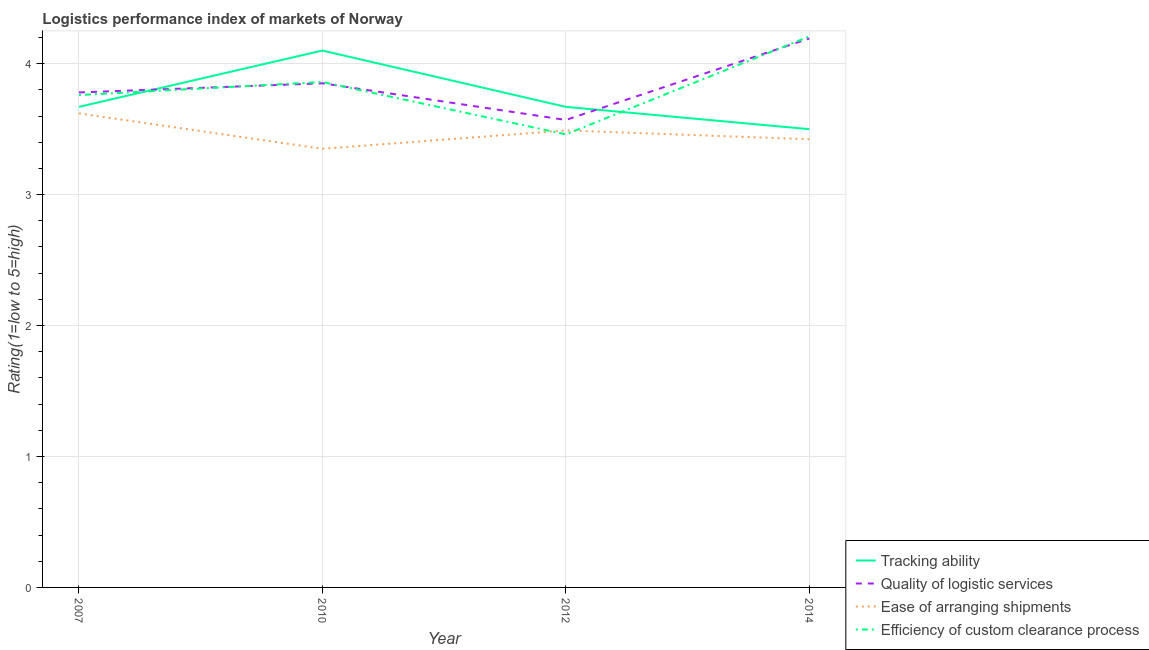Does the line corresponding to lpi rating of ease of arranging shipments intersect with the line corresponding to lpi rating of tracking ability?
Offer a terse response. No. Is the number of lines equal to the number of legend labels?
Your answer should be compact. Yes. What is the lpi rating of ease of arranging shipments in 2010?
Offer a very short reply. 3.35. Across all years, what is the maximum lpi rating of quality of logistic services?
Offer a very short reply. 4.19. Across all years, what is the minimum lpi rating of tracking ability?
Provide a succinct answer. 3.5. In which year was the lpi rating of tracking ability maximum?
Make the answer very short. 2010. What is the total lpi rating of tracking ability in the graph?
Your response must be concise. 14.94. What is the difference between the lpi rating of quality of logistic services in 2010 and that in 2012?
Provide a succinct answer. 0.28. What is the difference between the lpi rating of quality of logistic services in 2007 and the lpi rating of tracking ability in 2010?
Make the answer very short. -0.32. What is the average lpi rating of tracking ability per year?
Provide a succinct answer. 3.73. In the year 2012, what is the difference between the lpi rating of tracking ability and lpi rating of efficiency of custom clearance process?
Offer a very short reply. 0.21. What is the ratio of the lpi rating of quality of logistic services in 2012 to that in 2014?
Ensure brevity in your answer.  0.85. Is the lpi rating of tracking ability in 2007 less than that in 2012?
Provide a short and direct response. No. What is the difference between the highest and the second highest lpi rating of tracking ability?
Your response must be concise. 0.43. What is the difference between the highest and the lowest lpi rating of tracking ability?
Offer a terse response. 0.6. In how many years, is the lpi rating of tracking ability greater than the average lpi rating of tracking ability taken over all years?
Provide a short and direct response. 1. Is it the case that in every year, the sum of the lpi rating of ease of arranging shipments and lpi rating of quality of logistic services is greater than the sum of lpi rating of tracking ability and lpi rating of efficiency of custom clearance process?
Keep it short and to the point. No. Is it the case that in every year, the sum of the lpi rating of tracking ability and lpi rating of quality of logistic services is greater than the lpi rating of ease of arranging shipments?
Keep it short and to the point. Yes. Does the lpi rating of efficiency of custom clearance process monotonically increase over the years?
Your answer should be compact. No. Is the lpi rating of quality of logistic services strictly greater than the lpi rating of ease of arranging shipments over the years?
Provide a succinct answer. Yes. Is the lpi rating of ease of arranging shipments strictly less than the lpi rating of efficiency of custom clearance process over the years?
Make the answer very short. No. How many lines are there?
Keep it short and to the point. 4. How many years are there in the graph?
Make the answer very short. 4. Are the values on the major ticks of Y-axis written in scientific E-notation?
Ensure brevity in your answer.  No. Does the graph contain any zero values?
Give a very brief answer. No. Where does the legend appear in the graph?
Make the answer very short. Bottom right. How many legend labels are there?
Offer a terse response. 4. How are the legend labels stacked?
Your answer should be very brief. Vertical. What is the title of the graph?
Offer a very short reply. Logistics performance index of markets of Norway. What is the label or title of the X-axis?
Give a very brief answer. Year. What is the label or title of the Y-axis?
Offer a terse response. Rating(1=low to 5=high). What is the Rating(1=low to 5=high) in Tracking ability in 2007?
Keep it short and to the point. 3.67. What is the Rating(1=low to 5=high) of Quality of logistic services in 2007?
Your response must be concise. 3.78. What is the Rating(1=low to 5=high) of Ease of arranging shipments in 2007?
Give a very brief answer. 3.62. What is the Rating(1=low to 5=high) in Efficiency of custom clearance process in 2007?
Your answer should be compact. 3.76. What is the Rating(1=low to 5=high) in Tracking ability in 2010?
Your answer should be compact. 4.1. What is the Rating(1=low to 5=high) in Quality of logistic services in 2010?
Keep it short and to the point. 3.85. What is the Rating(1=low to 5=high) in Ease of arranging shipments in 2010?
Your response must be concise. 3.35. What is the Rating(1=low to 5=high) in Efficiency of custom clearance process in 2010?
Provide a succinct answer. 3.86. What is the Rating(1=low to 5=high) in Tracking ability in 2012?
Your answer should be compact. 3.67. What is the Rating(1=low to 5=high) in Quality of logistic services in 2012?
Offer a very short reply. 3.57. What is the Rating(1=low to 5=high) in Ease of arranging shipments in 2012?
Offer a very short reply. 3.49. What is the Rating(1=low to 5=high) of Efficiency of custom clearance process in 2012?
Ensure brevity in your answer.  3.46. What is the Rating(1=low to 5=high) of Tracking ability in 2014?
Provide a succinct answer. 3.5. What is the Rating(1=low to 5=high) in Quality of logistic services in 2014?
Give a very brief answer. 4.19. What is the Rating(1=low to 5=high) in Ease of arranging shipments in 2014?
Your answer should be very brief. 3.42. What is the Rating(1=low to 5=high) in Efficiency of custom clearance process in 2014?
Make the answer very short. 4.21. Across all years, what is the maximum Rating(1=low to 5=high) of Quality of logistic services?
Your response must be concise. 4.19. Across all years, what is the maximum Rating(1=low to 5=high) in Ease of arranging shipments?
Keep it short and to the point. 3.62. Across all years, what is the maximum Rating(1=low to 5=high) of Efficiency of custom clearance process?
Ensure brevity in your answer.  4.21. Across all years, what is the minimum Rating(1=low to 5=high) in Tracking ability?
Offer a very short reply. 3.5. Across all years, what is the minimum Rating(1=low to 5=high) of Quality of logistic services?
Your response must be concise. 3.57. Across all years, what is the minimum Rating(1=low to 5=high) of Ease of arranging shipments?
Ensure brevity in your answer.  3.35. Across all years, what is the minimum Rating(1=low to 5=high) of Efficiency of custom clearance process?
Ensure brevity in your answer.  3.46. What is the total Rating(1=low to 5=high) in Tracking ability in the graph?
Provide a succinct answer. 14.94. What is the total Rating(1=low to 5=high) in Quality of logistic services in the graph?
Your answer should be compact. 15.39. What is the total Rating(1=low to 5=high) in Ease of arranging shipments in the graph?
Keep it short and to the point. 13.88. What is the total Rating(1=low to 5=high) in Efficiency of custom clearance process in the graph?
Your answer should be very brief. 15.29. What is the difference between the Rating(1=low to 5=high) in Tracking ability in 2007 and that in 2010?
Offer a very short reply. -0.43. What is the difference between the Rating(1=low to 5=high) of Quality of logistic services in 2007 and that in 2010?
Make the answer very short. -0.07. What is the difference between the Rating(1=low to 5=high) of Ease of arranging shipments in 2007 and that in 2010?
Provide a succinct answer. 0.27. What is the difference between the Rating(1=low to 5=high) in Quality of logistic services in 2007 and that in 2012?
Provide a short and direct response. 0.21. What is the difference between the Rating(1=low to 5=high) of Ease of arranging shipments in 2007 and that in 2012?
Offer a very short reply. 0.13. What is the difference between the Rating(1=low to 5=high) of Efficiency of custom clearance process in 2007 and that in 2012?
Your answer should be very brief. 0.3. What is the difference between the Rating(1=low to 5=high) in Tracking ability in 2007 and that in 2014?
Give a very brief answer. 0.17. What is the difference between the Rating(1=low to 5=high) of Quality of logistic services in 2007 and that in 2014?
Your answer should be compact. -0.41. What is the difference between the Rating(1=low to 5=high) in Ease of arranging shipments in 2007 and that in 2014?
Ensure brevity in your answer.  0.2. What is the difference between the Rating(1=low to 5=high) of Efficiency of custom clearance process in 2007 and that in 2014?
Your answer should be very brief. -0.45. What is the difference between the Rating(1=low to 5=high) of Tracking ability in 2010 and that in 2012?
Offer a very short reply. 0.43. What is the difference between the Rating(1=low to 5=high) in Quality of logistic services in 2010 and that in 2012?
Your answer should be compact. 0.28. What is the difference between the Rating(1=low to 5=high) of Ease of arranging shipments in 2010 and that in 2012?
Your answer should be very brief. -0.14. What is the difference between the Rating(1=low to 5=high) in Efficiency of custom clearance process in 2010 and that in 2012?
Provide a short and direct response. 0.4. What is the difference between the Rating(1=low to 5=high) in Tracking ability in 2010 and that in 2014?
Make the answer very short. 0.6. What is the difference between the Rating(1=low to 5=high) in Quality of logistic services in 2010 and that in 2014?
Your response must be concise. -0.34. What is the difference between the Rating(1=low to 5=high) in Ease of arranging shipments in 2010 and that in 2014?
Make the answer very short. -0.07. What is the difference between the Rating(1=low to 5=high) of Efficiency of custom clearance process in 2010 and that in 2014?
Offer a terse response. -0.35. What is the difference between the Rating(1=low to 5=high) in Tracking ability in 2012 and that in 2014?
Offer a very short reply. 0.17. What is the difference between the Rating(1=low to 5=high) of Quality of logistic services in 2012 and that in 2014?
Your response must be concise. -0.62. What is the difference between the Rating(1=low to 5=high) of Ease of arranging shipments in 2012 and that in 2014?
Provide a succinct answer. 0.07. What is the difference between the Rating(1=low to 5=high) of Efficiency of custom clearance process in 2012 and that in 2014?
Make the answer very short. -0.75. What is the difference between the Rating(1=low to 5=high) in Tracking ability in 2007 and the Rating(1=low to 5=high) in Quality of logistic services in 2010?
Your answer should be very brief. -0.18. What is the difference between the Rating(1=low to 5=high) of Tracking ability in 2007 and the Rating(1=low to 5=high) of Ease of arranging shipments in 2010?
Provide a succinct answer. 0.32. What is the difference between the Rating(1=low to 5=high) of Tracking ability in 2007 and the Rating(1=low to 5=high) of Efficiency of custom clearance process in 2010?
Keep it short and to the point. -0.19. What is the difference between the Rating(1=low to 5=high) of Quality of logistic services in 2007 and the Rating(1=low to 5=high) of Ease of arranging shipments in 2010?
Give a very brief answer. 0.43. What is the difference between the Rating(1=low to 5=high) of Quality of logistic services in 2007 and the Rating(1=low to 5=high) of Efficiency of custom clearance process in 2010?
Give a very brief answer. -0.08. What is the difference between the Rating(1=low to 5=high) of Ease of arranging shipments in 2007 and the Rating(1=low to 5=high) of Efficiency of custom clearance process in 2010?
Your answer should be very brief. -0.24. What is the difference between the Rating(1=low to 5=high) in Tracking ability in 2007 and the Rating(1=low to 5=high) in Quality of logistic services in 2012?
Offer a very short reply. 0.1. What is the difference between the Rating(1=low to 5=high) of Tracking ability in 2007 and the Rating(1=low to 5=high) of Ease of arranging shipments in 2012?
Offer a very short reply. 0.18. What is the difference between the Rating(1=low to 5=high) in Tracking ability in 2007 and the Rating(1=low to 5=high) in Efficiency of custom clearance process in 2012?
Provide a succinct answer. 0.21. What is the difference between the Rating(1=low to 5=high) in Quality of logistic services in 2007 and the Rating(1=low to 5=high) in Ease of arranging shipments in 2012?
Make the answer very short. 0.29. What is the difference between the Rating(1=low to 5=high) in Quality of logistic services in 2007 and the Rating(1=low to 5=high) in Efficiency of custom clearance process in 2012?
Make the answer very short. 0.32. What is the difference between the Rating(1=low to 5=high) of Ease of arranging shipments in 2007 and the Rating(1=low to 5=high) of Efficiency of custom clearance process in 2012?
Provide a short and direct response. 0.16. What is the difference between the Rating(1=low to 5=high) of Tracking ability in 2007 and the Rating(1=low to 5=high) of Quality of logistic services in 2014?
Your response must be concise. -0.52. What is the difference between the Rating(1=low to 5=high) of Tracking ability in 2007 and the Rating(1=low to 5=high) of Ease of arranging shipments in 2014?
Give a very brief answer. 0.25. What is the difference between the Rating(1=low to 5=high) in Tracking ability in 2007 and the Rating(1=low to 5=high) in Efficiency of custom clearance process in 2014?
Keep it short and to the point. -0.54. What is the difference between the Rating(1=low to 5=high) of Quality of logistic services in 2007 and the Rating(1=low to 5=high) of Ease of arranging shipments in 2014?
Offer a very short reply. 0.36. What is the difference between the Rating(1=low to 5=high) in Quality of logistic services in 2007 and the Rating(1=low to 5=high) in Efficiency of custom clearance process in 2014?
Give a very brief answer. -0.43. What is the difference between the Rating(1=low to 5=high) in Ease of arranging shipments in 2007 and the Rating(1=low to 5=high) in Efficiency of custom clearance process in 2014?
Your response must be concise. -0.59. What is the difference between the Rating(1=low to 5=high) in Tracking ability in 2010 and the Rating(1=low to 5=high) in Quality of logistic services in 2012?
Keep it short and to the point. 0.53. What is the difference between the Rating(1=low to 5=high) in Tracking ability in 2010 and the Rating(1=low to 5=high) in Ease of arranging shipments in 2012?
Your answer should be compact. 0.61. What is the difference between the Rating(1=low to 5=high) of Tracking ability in 2010 and the Rating(1=low to 5=high) of Efficiency of custom clearance process in 2012?
Make the answer very short. 0.64. What is the difference between the Rating(1=low to 5=high) of Quality of logistic services in 2010 and the Rating(1=low to 5=high) of Ease of arranging shipments in 2012?
Your answer should be compact. 0.36. What is the difference between the Rating(1=low to 5=high) of Quality of logistic services in 2010 and the Rating(1=low to 5=high) of Efficiency of custom clearance process in 2012?
Make the answer very short. 0.39. What is the difference between the Rating(1=low to 5=high) in Ease of arranging shipments in 2010 and the Rating(1=low to 5=high) in Efficiency of custom clearance process in 2012?
Make the answer very short. -0.11. What is the difference between the Rating(1=low to 5=high) in Tracking ability in 2010 and the Rating(1=low to 5=high) in Quality of logistic services in 2014?
Your answer should be compact. -0.09. What is the difference between the Rating(1=low to 5=high) in Tracking ability in 2010 and the Rating(1=low to 5=high) in Ease of arranging shipments in 2014?
Keep it short and to the point. 0.68. What is the difference between the Rating(1=low to 5=high) of Tracking ability in 2010 and the Rating(1=low to 5=high) of Efficiency of custom clearance process in 2014?
Ensure brevity in your answer.  -0.11. What is the difference between the Rating(1=low to 5=high) in Quality of logistic services in 2010 and the Rating(1=low to 5=high) in Ease of arranging shipments in 2014?
Provide a succinct answer. 0.43. What is the difference between the Rating(1=low to 5=high) of Quality of logistic services in 2010 and the Rating(1=low to 5=high) of Efficiency of custom clearance process in 2014?
Provide a short and direct response. -0.36. What is the difference between the Rating(1=low to 5=high) of Ease of arranging shipments in 2010 and the Rating(1=low to 5=high) of Efficiency of custom clearance process in 2014?
Ensure brevity in your answer.  -0.86. What is the difference between the Rating(1=low to 5=high) of Tracking ability in 2012 and the Rating(1=low to 5=high) of Quality of logistic services in 2014?
Provide a succinct answer. -0.52. What is the difference between the Rating(1=low to 5=high) of Tracking ability in 2012 and the Rating(1=low to 5=high) of Ease of arranging shipments in 2014?
Make the answer very short. 0.25. What is the difference between the Rating(1=low to 5=high) of Tracking ability in 2012 and the Rating(1=low to 5=high) of Efficiency of custom clearance process in 2014?
Your response must be concise. -0.54. What is the difference between the Rating(1=low to 5=high) of Quality of logistic services in 2012 and the Rating(1=low to 5=high) of Ease of arranging shipments in 2014?
Your answer should be compact. 0.15. What is the difference between the Rating(1=low to 5=high) in Quality of logistic services in 2012 and the Rating(1=low to 5=high) in Efficiency of custom clearance process in 2014?
Keep it short and to the point. -0.64. What is the difference between the Rating(1=low to 5=high) of Ease of arranging shipments in 2012 and the Rating(1=low to 5=high) of Efficiency of custom clearance process in 2014?
Offer a very short reply. -0.72. What is the average Rating(1=low to 5=high) in Tracking ability per year?
Make the answer very short. 3.73. What is the average Rating(1=low to 5=high) of Quality of logistic services per year?
Offer a very short reply. 3.85. What is the average Rating(1=low to 5=high) in Ease of arranging shipments per year?
Make the answer very short. 3.47. What is the average Rating(1=low to 5=high) in Efficiency of custom clearance process per year?
Offer a very short reply. 3.82. In the year 2007, what is the difference between the Rating(1=low to 5=high) in Tracking ability and Rating(1=low to 5=high) in Quality of logistic services?
Offer a very short reply. -0.11. In the year 2007, what is the difference between the Rating(1=low to 5=high) in Tracking ability and Rating(1=low to 5=high) in Ease of arranging shipments?
Give a very brief answer. 0.05. In the year 2007, what is the difference between the Rating(1=low to 5=high) in Tracking ability and Rating(1=low to 5=high) in Efficiency of custom clearance process?
Your answer should be very brief. -0.09. In the year 2007, what is the difference between the Rating(1=low to 5=high) in Quality of logistic services and Rating(1=low to 5=high) in Ease of arranging shipments?
Offer a very short reply. 0.16. In the year 2007, what is the difference between the Rating(1=low to 5=high) in Quality of logistic services and Rating(1=low to 5=high) in Efficiency of custom clearance process?
Ensure brevity in your answer.  0.02. In the year 2007, what is the difference between the Rating(1=low to 5=high) in Ease of arranging shipments and Rating(1=low to 5=high) in Efficiency of custom clearance process?
Your answer should be very brief. -0.14. In the year 2010, what is the difference between the Rating(1=low to 5=high) in Tracking ability and Rating(1=low to 5=high) in Quality of logistic services?
Offer a terse response. 0.25. In the year 2010, what is the difference between the Rating(1=low to 5=high) of Tracking ability and Rating(1=low to 5=high) of Efficiency of custom clearance process?
Offer a very short reply. 0.24. In the year 2010, what is the difference between the Rating(1=low to 5=high) in Quality of logistic services and Rating(1=low to 5=high) in Ease of arranging shipments?
Your response must be concise. 0.5. In the year 2010, what is the difference between the Rating(1=low to 5=high) in Quality of logistic services and Rating(1=low to 5=high) in Efficiency of custom clearance process?
Offer a terse response. -0.01. In the year 2010, what is the difference between the Rating(1=low to 5=high) in Ease of arranging shipments and Rating(1=low to 5=high) in Efficiency of custom clearance process?
Offer a very short reply. -0.51. In the year 2012, what is the difference between the Rating(1=low to 5=high) in Tracking ability and Rating(1=low to 5=high) in Ease of arranging shipments?
Your answer should be compact. 0.18. In the year 2012, what is the difference between the Rating(1=low to 5=high) in Tracking ability and Rating(1=low to 5=high) in Efficiency of custom clearance process?
Your response must be concise. 0.21. In the year 2012, what is the difference between the Rating(1=low to 5=high) in Quality of logistic services and Rating(1=low to 5=high) in Ease of arranging shipments?
Give a very brief answer. 0.08. In the year 2012, what is the difference between the Rating(1=low to 5=high) in Quality of logistic services and Rating(1=low to 5=high) in Efficiency of custom clearance process?
Offer a very short reply. 0.11. In the year 2014, what is the difference between the Rating(1=low to 5=high) in Tracking ability and Rating(1=low to 5=high) in Quality of logistic services?
Provide a succinct answer. -0.69. In the year 2014, what is the difference between the Rating(1=low to 5=high) of Tracking ability and Rating(1=low to 5=high) of Ease of arranging shipments?
Offer a terse response. 0.08. In the year 2014, what is the difference between the Rating(1=low to 5=high) of Tracking ability and Rating(1=low to 5=high) of Efficiency of custom clearance process?
Provide a succinct answer. -0.71. In the year 2014, what is the difference between the Rating(1=low to 5=high) of Quality of logistic services and Rating(1=low to 5=high) of Ease of arranging shipments?
Ensure brevity in your answer.  0.77. In the year 2014, what is the difference between the Rating(1=low to 5=high) of Quality of logistic services and Rating(1=low to 5=high) of Efficiency of custom clearance process?
Make the answer very short. -0.02. In the year 2014, what is the difference between the Rating(1=low to 5=high) of Ease of arranging shipments and Rating(1=low to 5=high) of Efficiency of custom clearance process?
Offer a very short reply. -0.79. What is the ratio of the Rating(1=low to 5=high) in Tracking ability in 2007 to that in 2010?
Keep it short and to the point. 0.9. What is the ratio of the Rating(1=low to 5=high) of Quality of logistic services in 2007 to that in 2010?
Provide a succinct answer. 0.98. What is the ratio of the Rating(1=low to 5=high) in Ease of arranging shipments in 2007 to that in 2010?
Make the answer very short. 1.08. What is the ratio of the Rating(1=low to 5=high) in Efficiency of custom clearance process in 2007 to that in 2010?
Provide a short and direct response. 0.97. What is the ratio of the Rating(1=low to 5=high) of Tracking ability in 2007 to that in 2012?
Keep it short and to the point. 1. What is the ratio of the Rating(1=low to 5=high) in Quality of logistic services in 2007 to that in 2012?
Ensure brevity in your answer.  1.06. What is the ratio of the Rating(1=low to 5=high) of Ease of arranging shipments in 2007 to that in 2012?
Your answer should be compact. 1.04. What is the ratio of the Rating(1=low to 5=high) of Efficiency of custom clearance process in 2007 to that in 2012?
Give a very brief answer. 1.09. What is the ratio of the Rating(1=low to 5=high) of Tracking ability in 2007 to that in 2014?
Your response must be concise. 1.05. What is the ratio of the Rating(1=low to 5=high) in Quality of logistic services in 2007 to that in 2014?
Keep it short and to the point. 0.9. What is the ratio of the Rating(1=low to 5=high) of Ease of arranging shipments in 2007 to that in 2014?
Provide a short and direct response. 1.06. What is the ratio of the Rating(1=low to 5=high) in Efficiency of custom clearance process in 2007 to that in 2014?
Keep it short and to the point. 0.89. What is the ratio of the Rating(1=low to 5=high) of Tracking ability in 2010 to that in 2012?
Provide a succinct answer. 1.12. What is the ratio of the Rating(1=low to 5=high) in Quality of logistic services in 2010 to that in 2012?
Your answer should be very brief. 1.08. What is the ratio of the Rating(1=low to 5=high) in Ease of arranging shipments in 2010 to that in 2012?
Your answer should be very brief. 0.96. What is the ratio of the Rating(1=low to 5=high) of Efficiency of custom clearance process in 2010 to that in 2012?
Ensure brevity in your answer.  1.12. What is the ratio of the Rating(1=low to 5=high) of Tracking ability in 2010 to that in 2014?
Provide a succinct answer. 1.17. What is the ratio of the Rating(1=low to 5=high) in Quality of logistic services in 2010 to that in 2014?
Your answer should be very brief. 0.92. What is the ratio of the Rating(1=low to 5=high) in Ease of arranging shipments in 2010 to that in 2014?
Provide a succinct answer. 0.98. What is the ratio of the Rating(1=low to 5=high) of Efficiency of custom clearance process in 2010 to that in 2014?
Make the answer very short. 0.92. What is the ratio of the Rating(1=low to 5=high) of Tracking ability in 2012 to that in 2014?
Offer a very short reply. 1.05. What is the ratio of the Rating(1=low to 5=high) in Quality of logistic services in 2012 to that in 2014?
Offer a very short reply. 0.85. What is the ratio of the Rating(1=low to 5=high) in Ease of arranging shipments in 2012 to that in 2014?
Provide a succinct answer. 1.02. What is the ratio of the Rating(1=low to 5=high) of Efficiency of custom clearance process in 2012 to that in 2014?
Your answer should be very brief. 0.82. What is the difference between the highest and the second highest Rating(1=low to 5=high) in Tracking ability?
Keep it short and to the point. 0.43. What is the difference between the highest and the second highest Rating(1=low to 5=high) in Quality of logistic services?
Provide a short and direct response. 0.34. What is the difference between the highest and the second highest Rating(1=low to 5=high) of Ease of arranging shipments?
Offer a very short reply. 0.13. What is the difference between the highest and the second highest Rating(1=low to 5=high) of Efficiency of custom clearance process?
Make the answer very short. 0.35. What is the difference between the highest and the lowest Rating(1=low to 5=high) of Tracking ability?
Make the answer very short. 0.6. What is the difference between the highest and the lowest Rating(1=low to 5=high) in Quality of logistic services?
Give a very brief answer. 0.62. What is the difference between the highest and the lowest Rating(1=low to 5=high) of Ease of arranging shipments?
Offer a terse response. 0.27. What is the difference between the highest and the lowest Rating(1=low to 5=high) of Efficiency of custom clearance process?
Offer a very short reply. 0.75. 